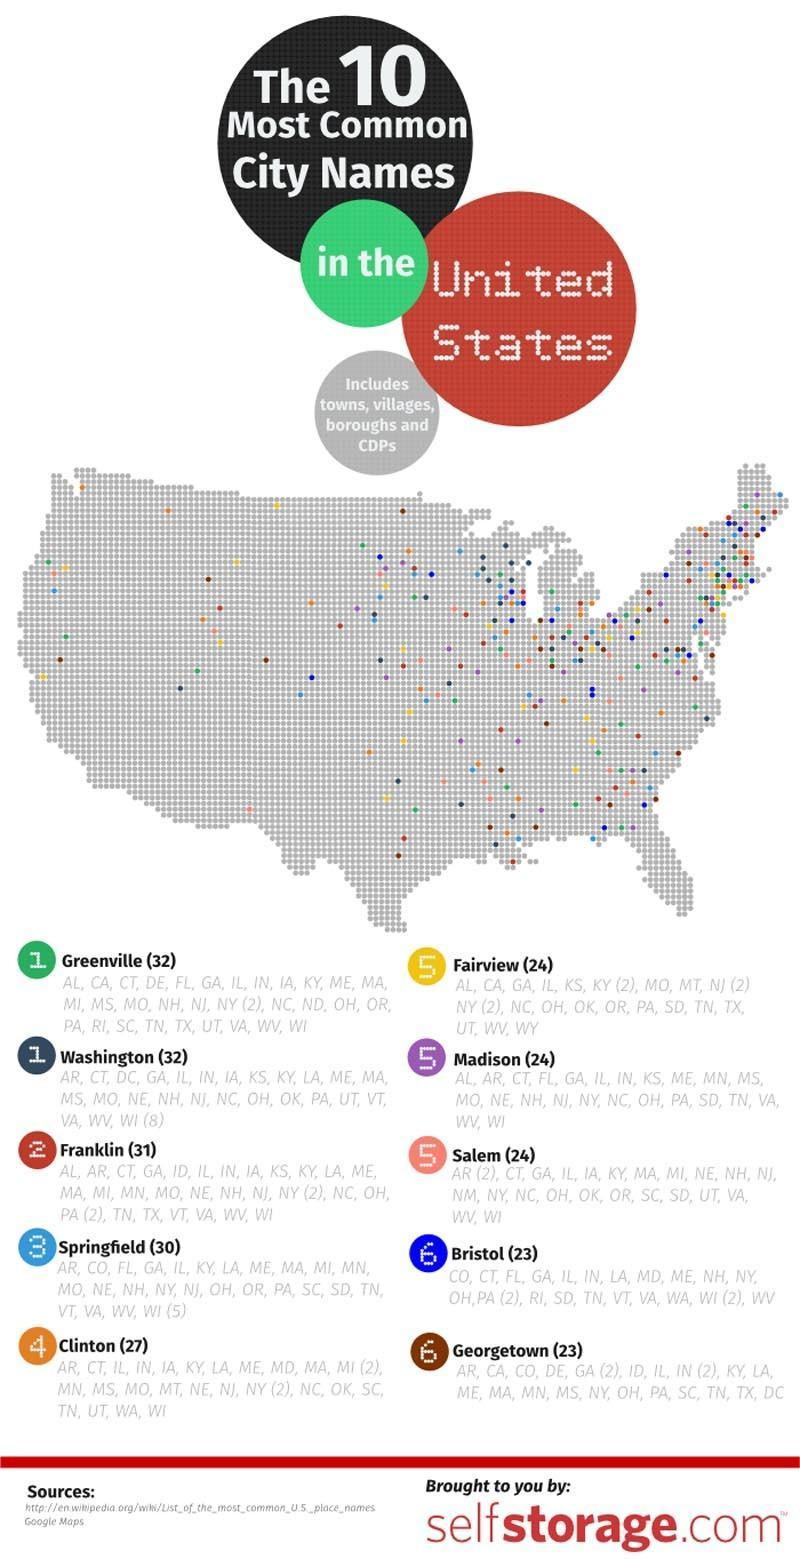In what color Fairview towns/villages are plotted- yellow, violet, pink, blue?
Answer the question with a short phrase. yellow Which is the second town/village code shown under the city Greenville? CA What is the written inside the green bubble near Greenville? 1 What is the color code of towns/villages in Franklin city- orange, blue, red, brown? red What is the color of the bubble close to city Greenville- yellow, green, red, violet? green In what color Georgetown towns/villages are plotted- yellow, brown, pink, blue? brown Which is the second town/village code shown under the city Bristol? CT 